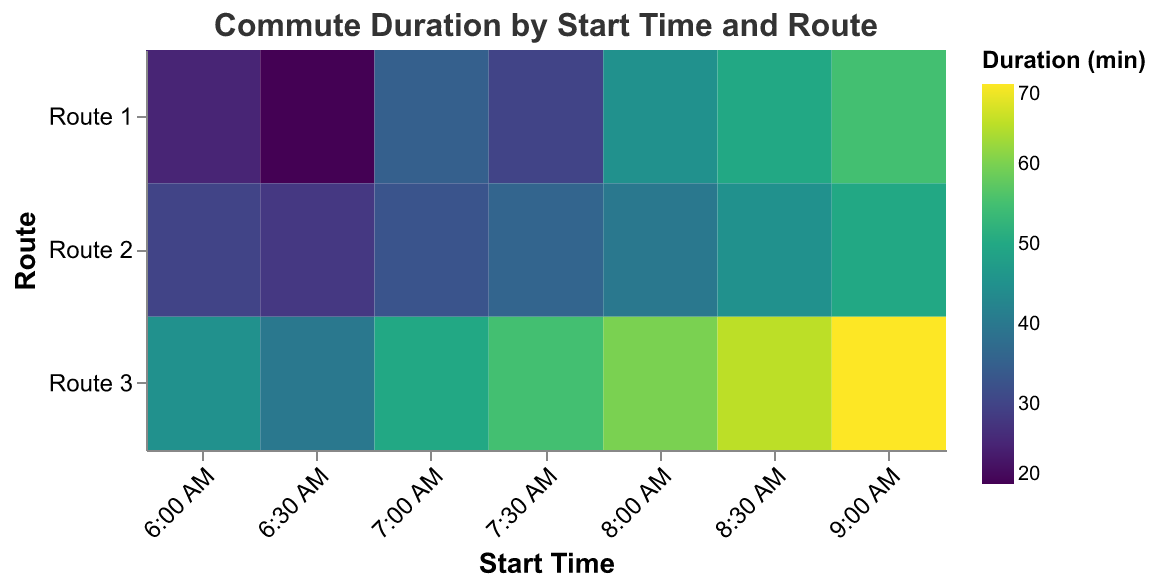What is the title of the heatmap? The title is a text element usually located at the top center of the figure. It gives a summary of what the visual data represents. Here, the title "Commute Duration by Start Time and Route" describes the subject matter of the heatmap.
Answer: Commute Duration by Start Time and Route Which route at 6:00 AM has the longest commute duration? To determine this, look at the row corresponding to 6:00 AM and identify the highest duration value among the different routes. The highest value for the 6:00 AM timeslot is 45 minutes for Route 3.
Answer: Route 3 Between 7:00 AM and 7:30 AM, which time slot experiences a higher average commute duration for Route 2? Calculate the average for both time slots for Route 2. At 7:00 AM, the duration is 33 minutes, and at 7:30 AM, it is 36 minutes. Compare these values to see which is higher.
Answer: 7:30 AM At what time does Route 1 have the shortest commute duration, and what is that duration? Check the durations for Route 1 across all time slots and identify the minimum value. The shortest duration for Route 1 is 20 minutes at 6:30 AM.
Answer: 6:30 AM, 20 minutes Which route and start time combination results in the longest commute duration in the dataset? Look for the maximum value in the color scale representing commute duration across the entire heatmap. The longest duration is 70 minutes at 9:00 AM for Route 3.
Answer: Route 3 at 9:00 AM How does the commute duration for Route 1 change from 8:00 AM to 9:00 AM? Compare the durations at 8:00 AM and 9:00 AM for Route 1. At 8:00 AM, it is 45 minutes, and at 9:00 AM, it is 55 minutes. The duration increases by 10 minutes.
Answer: Increases by 10 minutes What is the average commute duration for all routes at 7:00 AM? Calculate the average of the durations for all routes at 7:00 AM: (35 + 33 + 50) / 3 = 39.33 minutes.
Answer: 39.33 minutes Does Route 2 ever have a commute duration shorter than 30 minutes? Scan through the heatmap for Route 2 and check if any value is less than 30 minutes. The duration is 28 minutes at 6:30 AM.
Answer: Yes, at 6:30 AM Comparing Route 1 and Route 3, which one generally has longer commute times? Compare the durations for each route across all time slots. Route 3 consistently shows longer durations across the time slots.
Answer: Route 3 